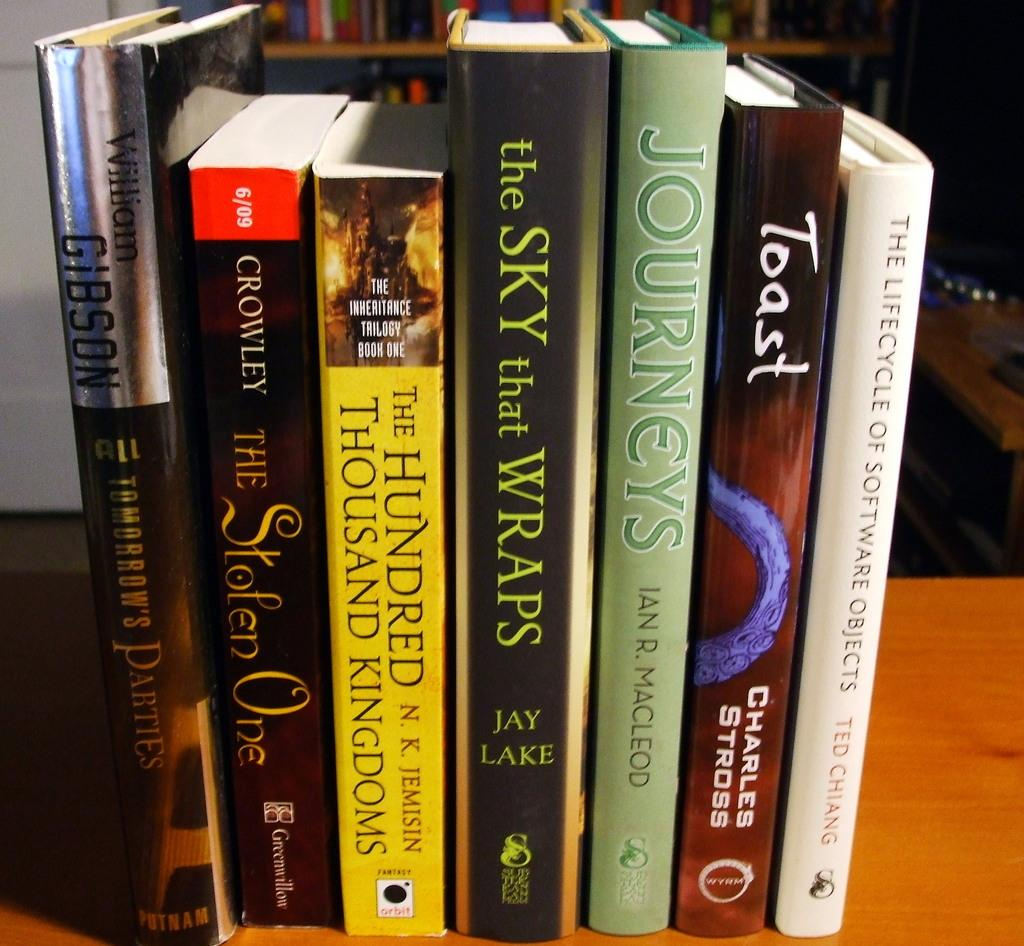<image>
Provide a brief description of the given image. a row of books with one titled 'the sky that wraps' by jay lake 